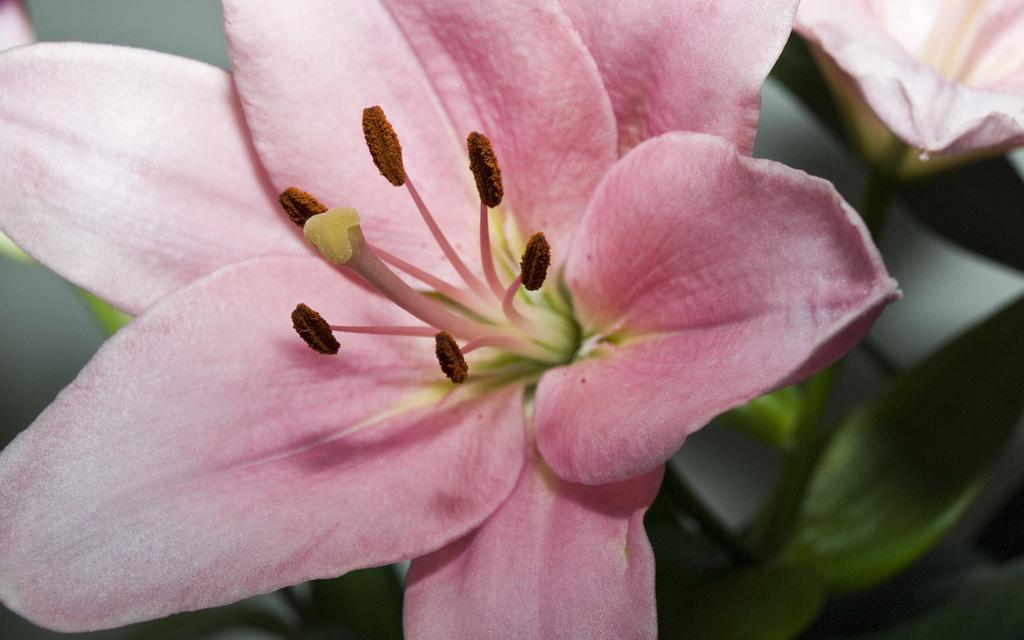Please provide a concise description of this image. In this picture there is a flower and the background is blurry. 